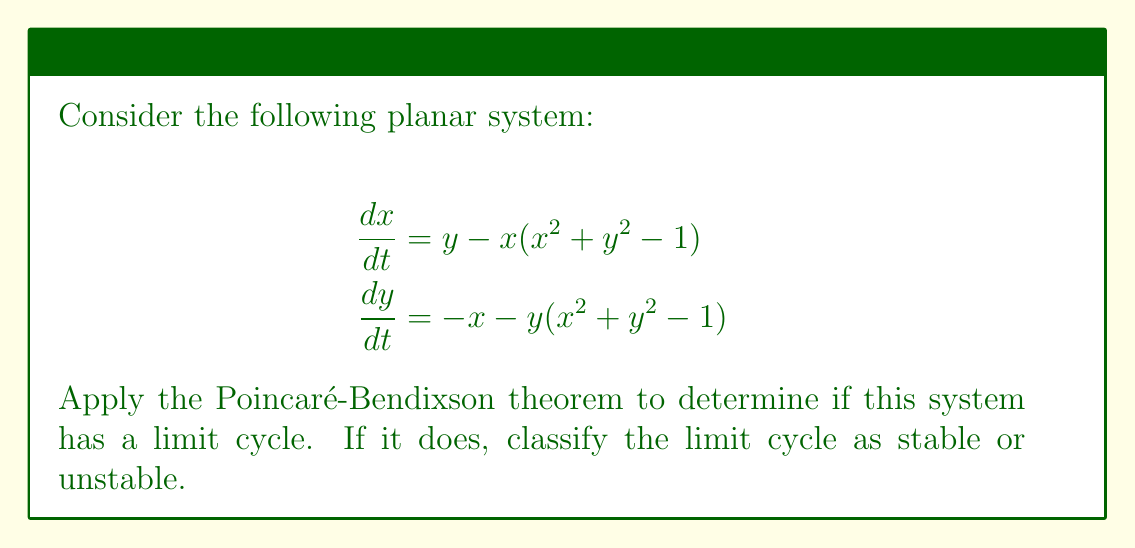Can you solve this math problem? 1. First, we need to identify the equilibrium points of the system. Set both equations to zero:

   $$y - x(x^2 + y^2 - 1) = 0$$
   $$-x - y(x^2 + y^2 - 1) = 0$$

2. From these equations, we can see that $(0,0)$ is an equilibrium point. Additionally, any point on the unit circle $x^2 + y^2 = 1$ is also an equilibrium point.

3. To apply the Poincaré-Bendixson theorem, we need to find a trapping region. Let's consider the behavior of the system for large $r = \sqrt{x^2 + y^2}$:

   $$\frac{d}{dt}(x^2 + y^2) = 2x\frac{dx}{dt} + 2y\frac{dy}{dt}$$
   $$= 2x(y - x(x^2 + y^2 - 1)) + 2y(-x - y(x^2 + y^2 - 1))$$
   $$= 2xy - 2x^2(x^2 + y^2 - 1) - 2xy - 2y^2(x^2 + y^2 - 1)$$
   $$= -2(x^2 + y^2)(x^2 + y^2 - 1)$$
   $$= -2r^2(r^2 - 1)$$

4. When $r > 1$, $\frac{d}{dt}(x^2 + y^2) < 0$, meaning trajectories move inward. When $r < 1$, $\frac{d}{dt}(x^2 + y^2) > 0$, meaning trajectories move outward.

5. This behavior creates a trapping region: trajectories starting outside the unit circle will move inward, while those starting inside will move outward. They cannot cross the unit circle because it consists of equilibrium points.

6. The origin $(0,0)$ is the only equilibrium point inside this trapping region. We can check its stability by linearizing the system:

   $$J = \begin{bmatrix} 
   -3x^2 - y^2 + 1 & 1 - 2xy \\
   -1 - 2xy & -x^2 - 3y^2 + 1
   \end{bmatrix}$$

   At $(0,0)$, $J = \begin{bmatrix} 1 & 1 \\ -1 & 1 \end{bmatrix}$

   The eigenvalues are $1 \pm i$, indicating an unstable spiral point.

7. By the Poincaré-Bendixson theorem, since we have a trapping region containing an unstable equilibrium point, there must exist a limit cycle within this region.

8. The limit cycle must be stable because trajectories from both inside and outside the unit circle are attracted to it.
Answer: The system has a stable limit cycle. 